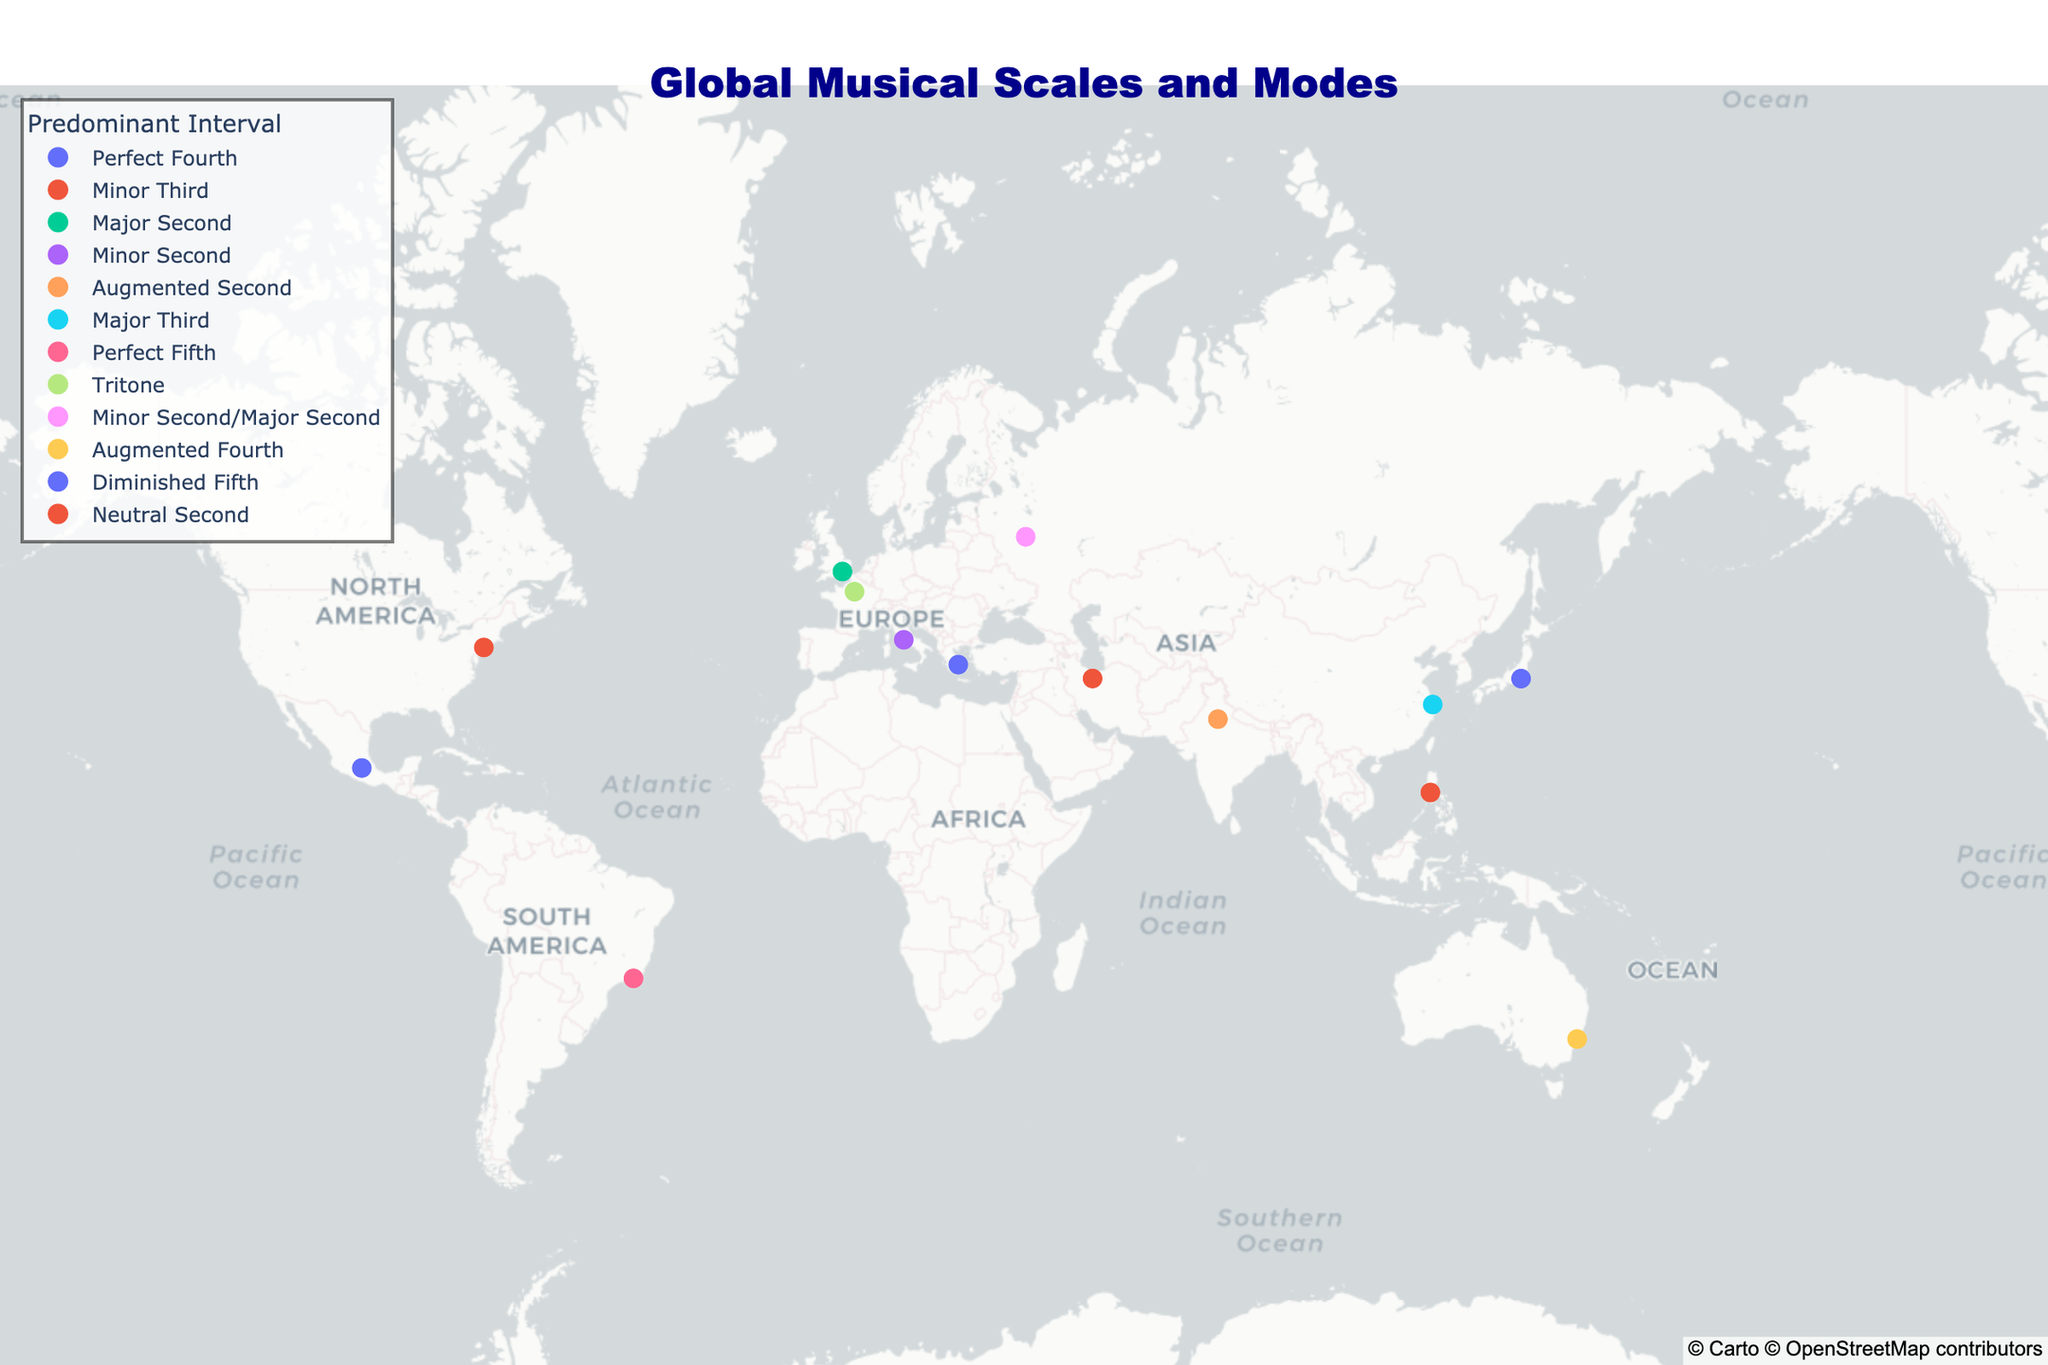What is the title of the map? The title of the map is written at the top, centered.
Answer: Global Musical Scales and Modes Which cultural tradition is associated with the Tritone interval? Look for the color representing Tritone and check the hover info for culture.
Answer: French How many different predominant intervals are represented on the map? Count the different colors in the legend under 'Predominant Interval'.
Answer: 10 Which cultural tradition is located in New York? Find the data point at the coordinates (40.7128, -74.0060) and check the hover info for culture.
Answer: American Which scale or mode is associated with the Australian culture? Find the data point for Australia and check the hover info under 'Scale/Mode'.
Answer: Lydian Mode Which country has a scale or mode with a Predominant Interval of an Augmented Second? Look for the point colored for Augmented Second and check the hover info for country.
Answer: India What is the relationship between the latitude of the Indonesian and Greek cultural traditions? Compare the latitude values for Indonesia and Greece.
Answer: Greek Latitude (37.9838) is higher than Indonesian Latitude (14.5995) What is the most common interval among the scales and modes represented? Count the number of times each interval appears in the legend.
Answer: Minor Second (appears twice) Which cultures have a minor third as their predominant interval? Identify points represented by the color for Minor Third and check the hover info for cultures.
Answer: American, Indonesian What's unique about the intervals in the Russian Octatonic Scale compared to others on the map? Look at the hover info for Russian culture and identify the interval description.
Answer: It has both Minor Second and Major Second 